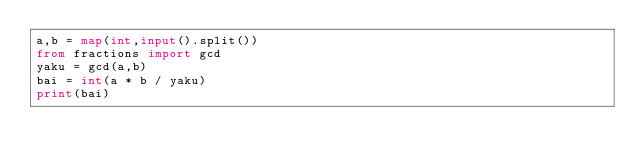Convert code to text. <code><loc_0><loc_0><loc_500><loc_500><_Python_>a,b = map(int,input().split())
from fractions import gcd
yaku = gcd(a,b)
bai = int(a * b / yaku)
print(bai)</code> 